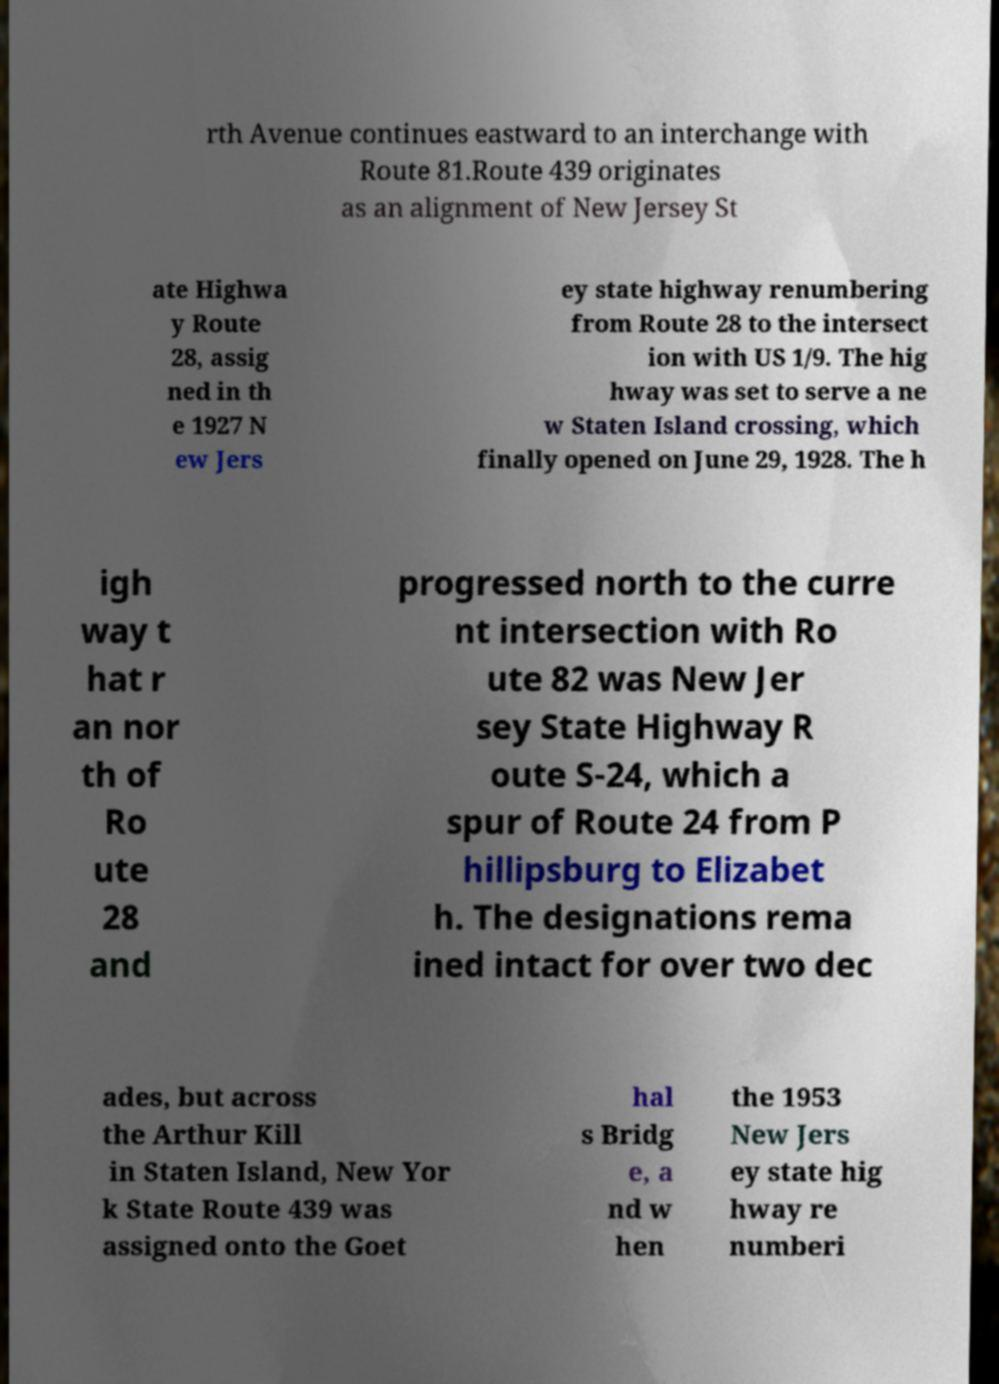Could you assist in decoding the text presented in this image and type it out clearly? rth Avenue continues eastward to an interchange with Route 81.Route 439 originates as an alignment of New Jersey St ate Highwa y Route 28, assig ned in th e 1927 N ew Jers ey state highway renumbering from Route 28 to the intersect ion with US 1/9. The hig hway was set to serve a ne w Staten Island crossing, which finally opened on June 29, 1928. The h igh way t hat r an nor th of Ro ute 28 and progressed north to the curre nt intersection with Ro ute 82 was New Jer sey State Highway R oute S-24, which a spur of Route 24 from P hillipsburg to Elizabet h. The designations rema ined intact for over two dec ades, but across the Arthur Kill in Staten Island, New Yor k State Route 439 was assigned onto the Goet hal s Bridg e, a nd w hen the 1953 New Jers ey state hig hway re numberi 